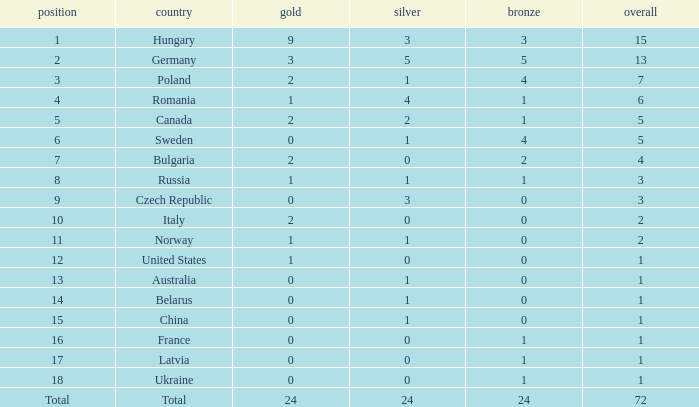What average silver has belarus as the nation, with a total less than 1? None. 